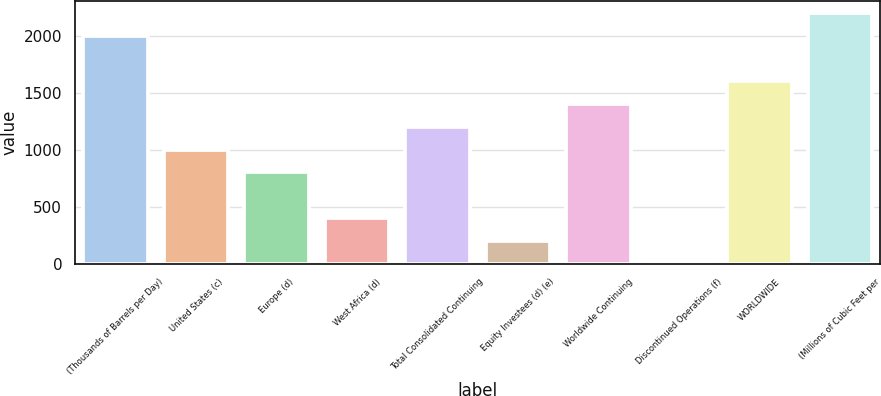Convert chart to OTSL. <chart><loc_0><loc_0><loc_500><loc_500><bar_chart><fcel>(Thousands of Barrels per Day)<fcel>United States (c)<fcel>Europe (d)<fcel>West Africa (d)<fcel>Total Consolidated Continuing<fcel>Equity Investees (d) (e)<fcel>Worldwide Continuing<fcel>Discontinued Operations (f)<fcel>WORLDWIDE<fcel>(Millions of Cubic Feet per<nl><fcel>2002<fcel>1003<fcel>803.2<fcel>403.6<fcel>1202.8<fcel>203.8<fcel>1402.6<fcel>4<fcel>1602.4<fcel>2201.8<nl></chart> 